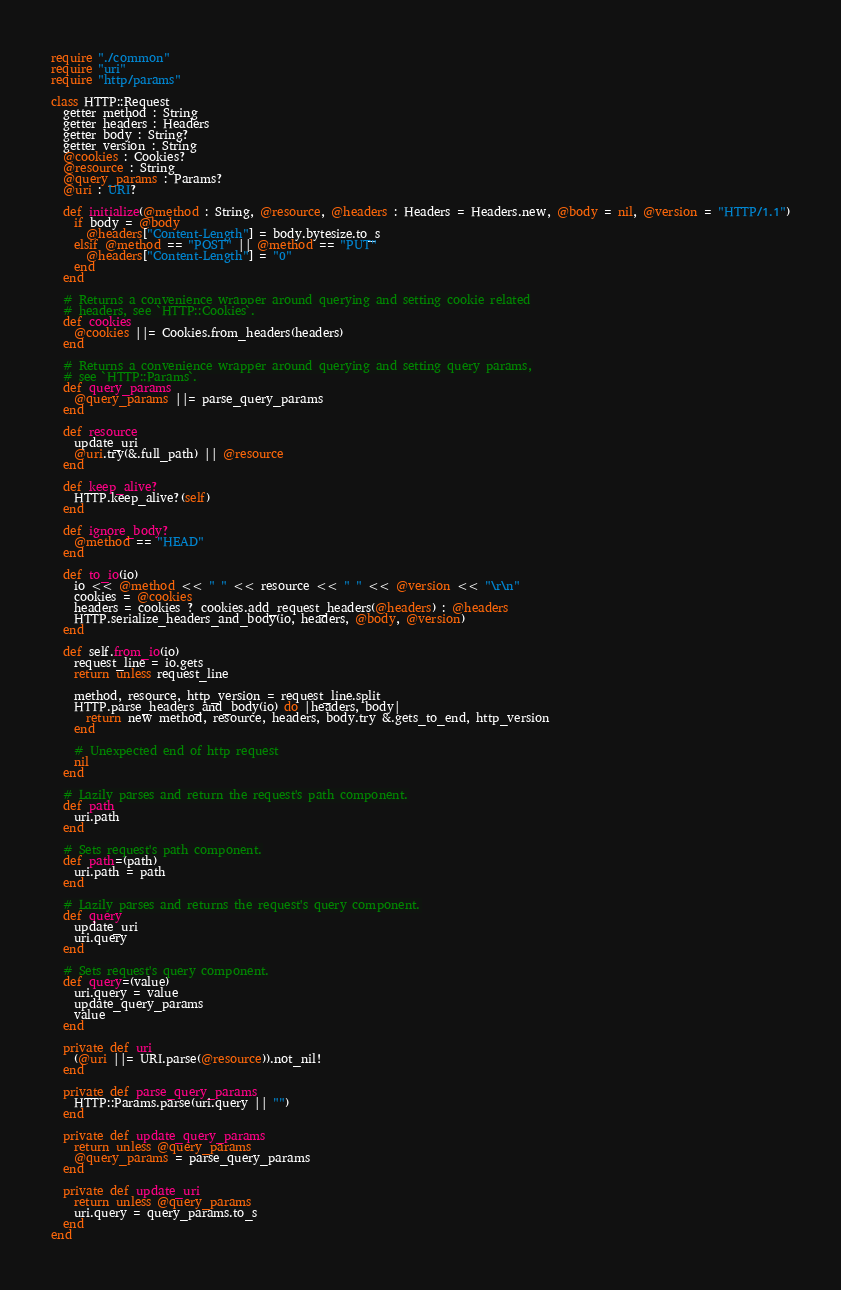<code> <loc_0><loc_0><loc_500><loc_500><_Crystal_>require "./common"
require "uri"
require "http/params"

class HTTP::Request
  getter method : String
  getter headers : Headers
  getter body : String?
  getter version : String
  @cookies : Cookies?
  @resource : String
  @query_params : Params?
  @uri : URI?

  def initialize(@method : String, @resource, @headers : Headers = Headers.new, @body = nil, @version = "HTTP/1.1")
    if body = @body
      @headers["Content-Length"] = body.bytesize.to_s
    elsif @method == "POST" || @method == "PUT"
      @headers["Content-Length"] = "0"
    end
  end

  # Returns a convenience wrapper around querying and setting cookie related
  # headers, see `HTTP::Cookies`.
  def cookies
    @cookies ||= Cookies.from_headers(headers)
  end

  # Returns a convenience wrapper around querying and setting query params,
  # see `HTTP::Params`.
  def query_params
    @query_params ||= parse_query_params
  end

  def resource
    update_uri
    @uri.try(&.full_path) || @resource
  end

  def keep_alive?
    HTTP.keep_alive?(self)
  end

  def ignore_body?
    @method == "HEAD"
  end

  def to_io(io)
    io << @method << " " << resource << " " << @version << "\r\n"
    cookies = @cookies
    headers = cookies ? cookies.add_request_headers(@headers) : @headers
    HTTP.serialize_headers_and_body(io, headers, @body, @version)
  end

  def self.from_io(io)
    request_line = io.gets
    return unless request_line

    method, resource, http_version = request_line.split
    HTTP.parse_headers_and_body(io) do |headers, body|
      return new method, resource, headers, body.try &.gets_to_end, http_version
    end

    # Unexpected end of http request
    nil
  end

  # Lazily parses and return the request's path component.
  def path
    uri.path
  end

  # Sets request's path component.
  def path=(path)
    uri.path = path
  end

  # Lazily parses and returns the request's query component.
  def query
    update_uri
    uri.query
  end

  # Sets request's query component.
  def query=(value)
    uri.query = value
    update_query_params
    value
  end

  private def uri
    (@uri ||= URI.parse(@resource)).not_nil!
  end

  private def parse_query_params
    HTTP::Params.parse(uri.query || "")
  end

  private def update_query_params
    return unless @query_params
    @query_params = parse_query_params
  end

  private def update_uri
    return unless @query_params
    uri.query = query_params.to_s
  end
end
</code> 